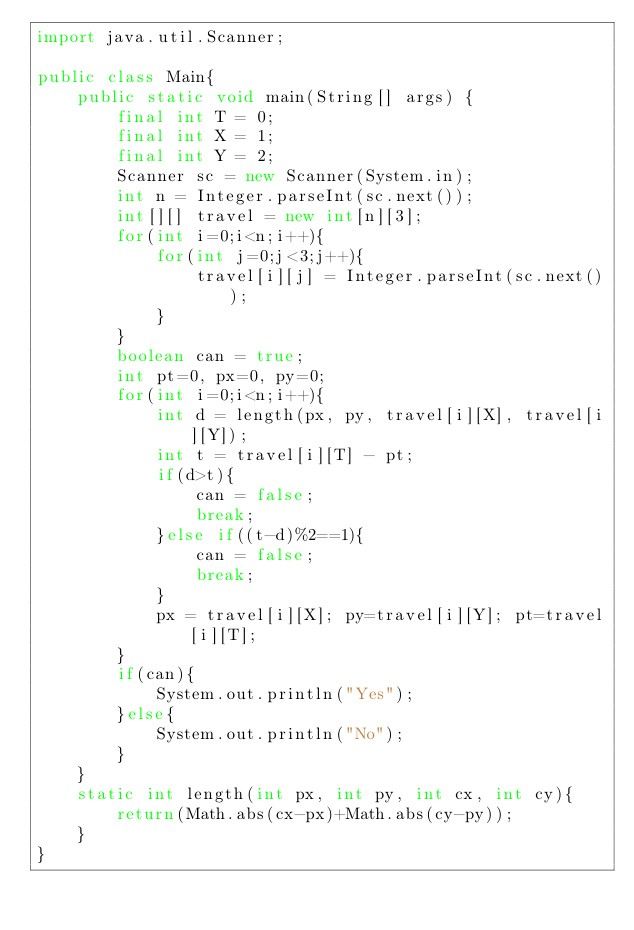Convert code to text. <code><loc_0><loc_0><loc_500><loc_500><_Java_>import java.util.Scanner;

public class Main{
    public static void main(String[] args) {
        final int T = 0;
        final int X = 1;
        final int Y = 2;
        Scanner sc = new Scanner(System.in);
        int n = Integer.parseInt(sc.next());
        int[][] travel = new int[n][3];
        for(int i=0;i<n;i++){
            for(int j=0;j<3;j++){
                travel[i][j] = Integer.parseInt(sc.next());
            }
        }
        boolean can = true;
        int pt=0, px=0, py=0;
        for(int i=0;i<n;i++){
            int d = length(px, py, travel[i][X], travel[i][Y]);
            int t = travel[i][T] - pt;
            if(d>t){
                can = false;
                break;
            }else if((t-d)%2==1){
                can = false;
                break;
            }
            px = travel[i][X]; py=travel[i][Y]; pt=travel[i][T];
        }
        if(can){
            System.out.println("Yes");
        }else{
            System.out.println("No");
        }
    }
    static int length(int px, int py, int cx, int cy){
        return(Math.abs(cx-px)+Math.abs(cy-py));
    }
}</code> 